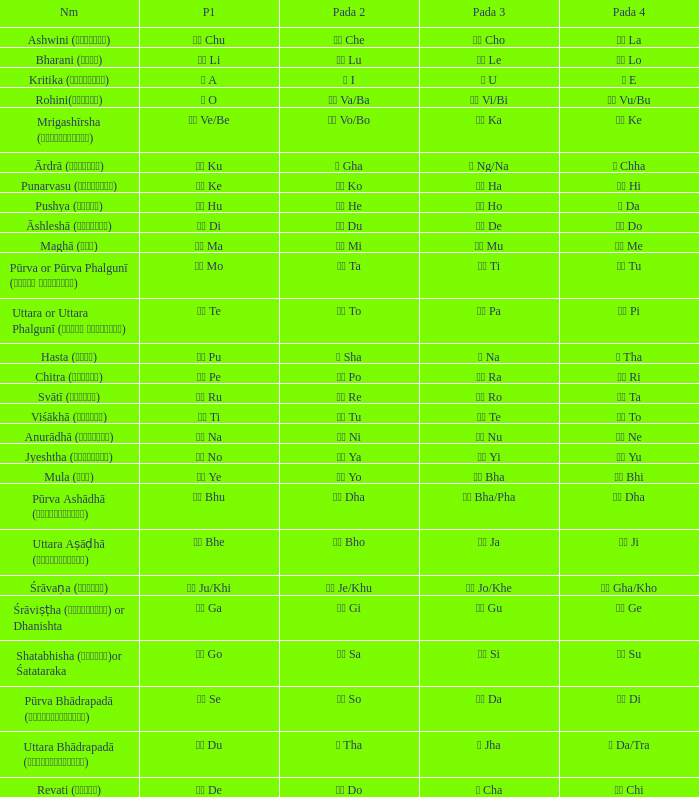Which pada 4 has a pada 2 of थ tha? ञ Da/Tra. 